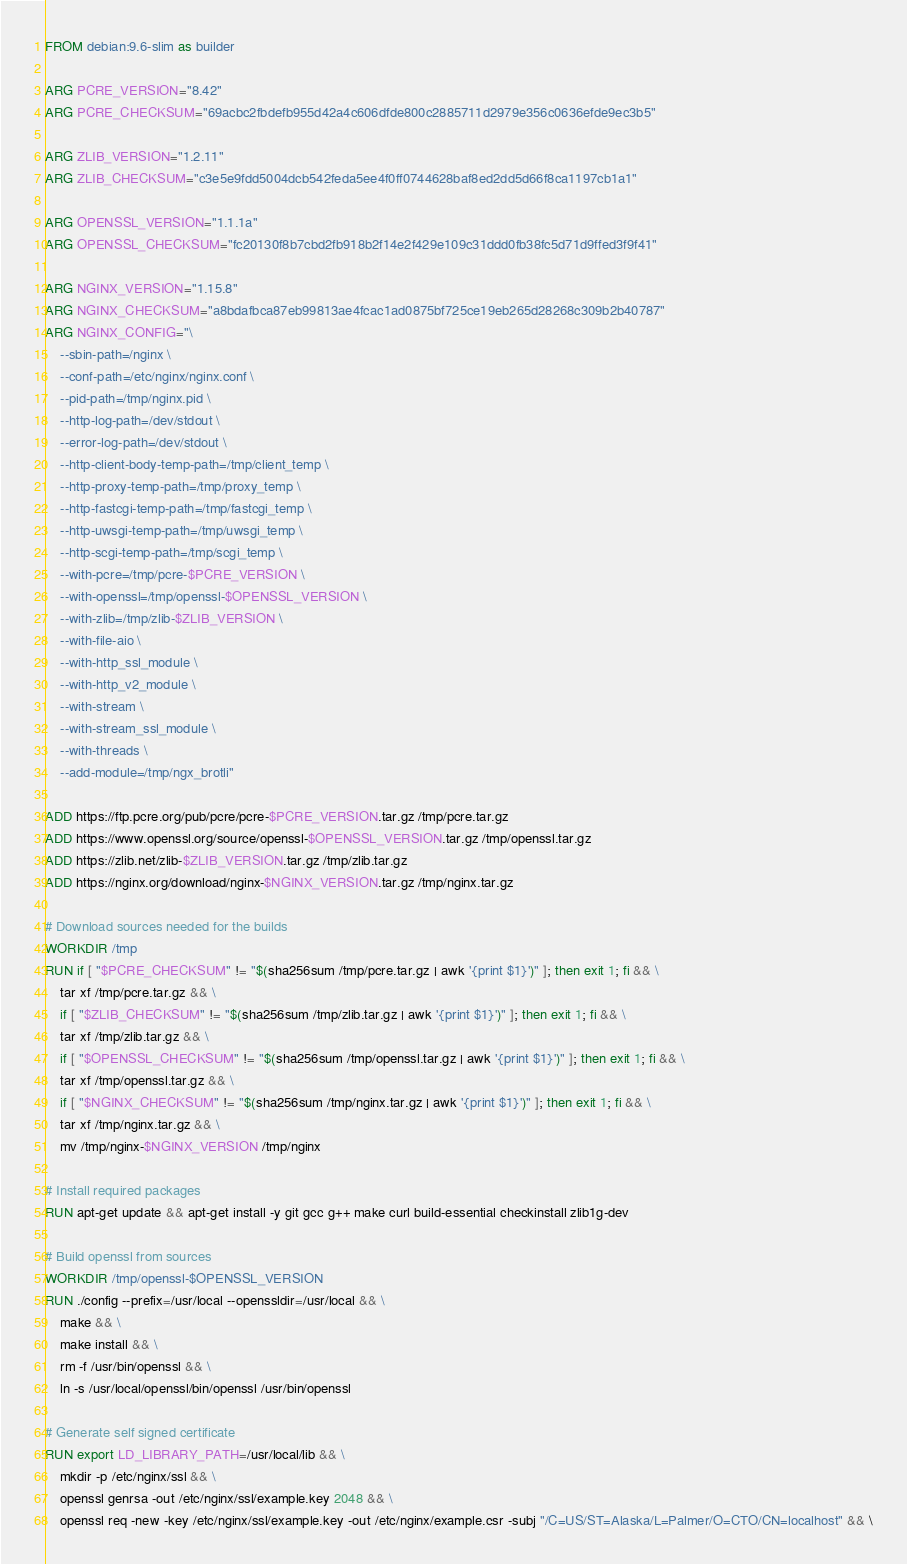Convert code to text. <code><loc_0><loc_0><loc_500><loc_500><_Dockerfile_>FROM debian:9.6-slim as builder

ARG PCRE_VERSION="8.42"
ARG PCRE_CHECKSUM="69acbc2fbdefb955d42a4c606dfde800c2885711d2979e356c0636efde9ec3b5"

ARG ZLIB_VERSION="1.2.11"
ARG ZLIB_CHECKSUM="c3e5e9fdd5004dcb542feda5ee4f0ff0744628baf8ed2dd5d66f8ca1197cb1a1"

ARG OPENSSL_VERSION="1.1.1a"
ARG OPENSSL_CHECKSUM="fc20130f8b7cbd2fb918b2f14e2f429e109c31ddd0fb38fc5d71d9ffed3f9f41"

ARG NGINX_VERSION="1.15.8"
ARG NGINX_CHECKSUM="a8bdafbca87eb99813ae4fcac1ad0875bf725ce19eb265d28268c309b2b40787"
ARG NGINX_CONFIG="\
    --sbin-path=/nginx \
    --conf-path=/etc/nginx/nginx.conf \
    --pid-path=/tmp/nginx.pid \
    --http-log-path=/dev/stdout \
    --error-log-path=/dev/stdout \
    --http-client-body-temp-path=/tmp/client_temp \
    --http-proxy-temp-path=/tmp/proxy_temp \
    --http-fastcgi-temp-path=/tmp/fastcgi_temp \
    --http-uwsgi-temp-path=/tmp/uwsgi_temp \
    --http-scgi-temp-path=/tmp/scgi_temp \
    --with-pcre=/tmp/pcre-$PCRE_VERSION \
    --with-openssl=/tmp/openssl-$OPENSSL_VERSION \
    --with-zlib=/tmp/zlib-$ZLIB_VERSION \
    --with-file-aio \
    --with-http_ssl_module \
    --with-http_v2_module \
    --with-stream \
    --with-stream_ssl_module \
    --with-threads \
    --add-module=/tmp/ngx_brotli"

ADD https://ftp.pcre.org/pub/pcre/pcre-$PCRE_VERSION.tar.gz /tmp/pcre.tar.gz
ADD https://www.openssl.org/source/openssl-$OPENSSL_VERSION.tar.gz /tmp/openssl.tar.gz
ADD https://zlib.net/zlib-$ZLIB_VERSION.tar.gz /tmp/zlib.tar.gz
ADD https://nginx.org/download/nginx-$NGINX_VERSION.tar.gz /tmp/nginx.tar.gz

# Download sources needed for the builds
WORKDIR /tmp
RUN if [ "$PCRE_CHECKSUM" != "$(sha256sum /tmp/pcre.tar.gz | awk '{print $1}')" ]; then exit 1; fi && \
    tar xf /tmp/pcre.tar.gz && \
    if [ "$ZLIB_CHECKSUM" != "$(sha256sum /tmp/zlib.tar.gz | awk '{print $1}')" ]; then exit 1; fi && \
    tar xf /tmp/zlib.tar.gz && \
    if [ "$OPENSSL_CHECKSUM" != "$(sha256sum /tmp/openssl.tar.gz | awk '{print $1}')" ]; then exit 1; fi && \
    tar xf /tmp/openssl.tar.gz && \
    if [ "$NGINX_CHECKSUM" != "$(sha256sum /tmp/nginx.tar.gz | awk '{print $1}')" ]; then exit 1; fi && \
    tar xf /tmp/nginx.tar.gz && \
    mv /tmp/nginx-$NGINX_VERSION /tmp/nginx

# Install required packages
RUN apt-get update && apt-get install -y git gcc g++ make curl build-essential checkinstall zlib1g-dev

# Build openssl from sources
WORKDIR /tmp/openssl-$OPENSSL_VERSION
RUN ./config --prefix=/usr/local --openssldir=/usr/local && \
    make && \
    make install && \
    rm -f /usr/bin/openssl && \
    ln -s /usr/local/openssl/bin/openssl /usr/bin/openssl

# Generate self signed certificate
RUN export LD_LIBRARY_PATH=/usr/local/lib && \
    mkdir -p /etc/nginx/ssl && \
    openssl genrsa -out /etc/nginx/ssl/example.key 2048 && \
    openssl req -new -key /etc/nginx/ssl/example.key -out /etc/nginx/example.csr -subj "/C=US/ST=Alaska/L=Palmer/O=CTO/CN=localhost" && \</code> 